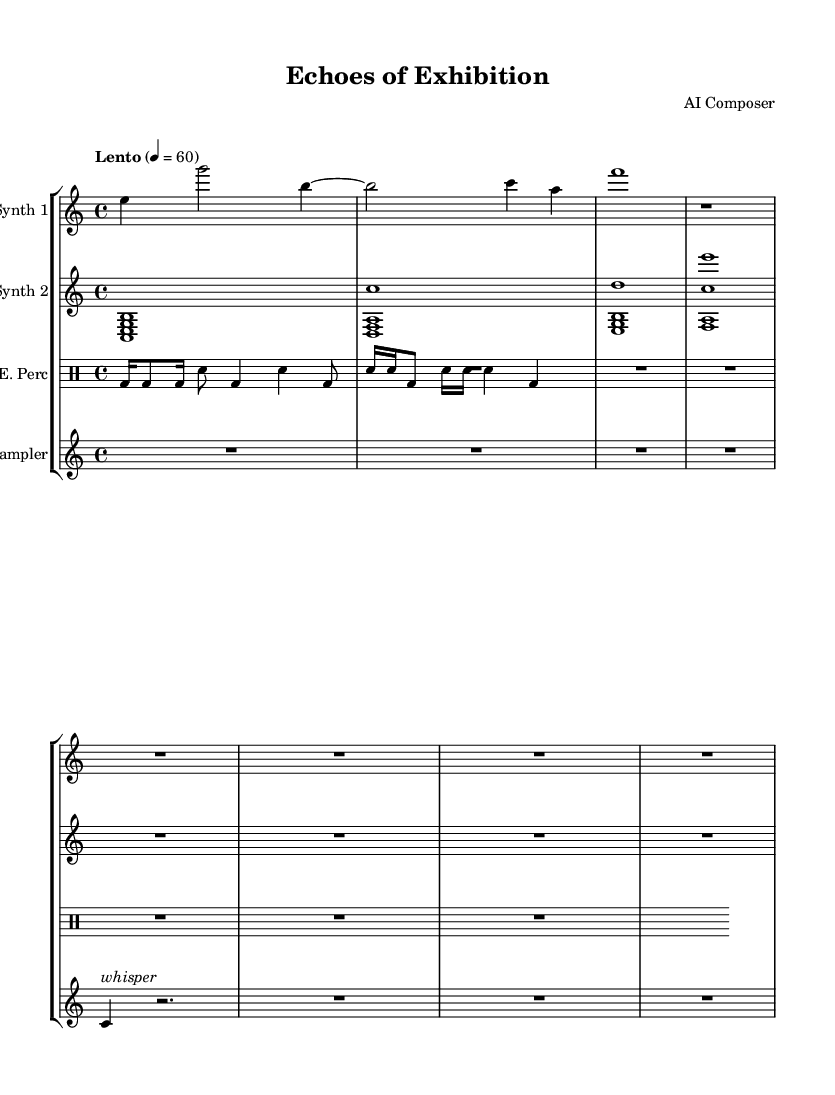What is the time signature of this music? The time signature is indicated at the beginning of the sheet music, which shows a 4 over 4, meaning there are four beats in each measure and the quarter note gets one beat.
Answer: 4/4 What is the tempo of the piece? The tempo marking "Lento" indicates a slow tempo, typically adhering to the quarter note equaling sixty beats per minute as indicated by the number following the tempo description.
Answer: Lento What instruments are featured in this piece? The instrument names are indicated at the beginning of each staff, showing "Synth 1," "Synth 2," "E. Perc" (Electronic Percussion), and "Sampler."
Answer: Synth 1, Synth 2, E. Perc, Sampler How many measures are there in the first part of Synth 1? Counting the measures in the Synth 1 staff, there are four distinct measures notated before the next staff begins, which are separated by the bar lines.
Answer: 4 What kind of rhythmic figure is predominantly used in the percussion part? The percussion part shows a mix of sixteenth and eighth notes, specifically a kick drum in sixteenth notes being played consistently along with snare hits, which reflects traditional and modern rhythmic patterns.
Answer: Sixteenth notes What is the dynamic marking for the Sampler part? The Sampler part features a dynamic marking of "whisper," indicated on the first note of the part, suggesting a very quiet, subdued sound for that section.
Answer: Whisper What effect does the rest in the sampler add to the piece? The rest in the Sampler part creates silence in the music, allowing for a contrast between the sound and moments of stillness that enhance the auditory experience akin to being within an art gallery.
Answer: Silence 